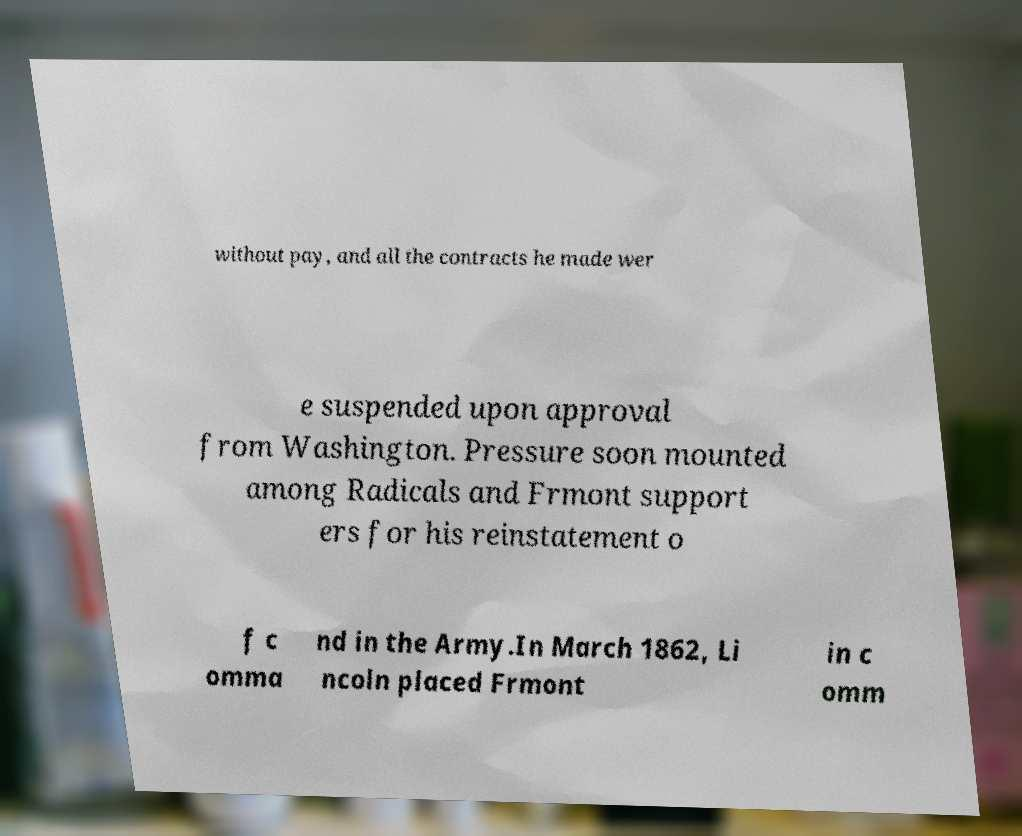For documentation purposes, I need the text within this image transcribed. Could you provide that? without pay, and all the contracts he made wer e suspended upon approval from Washington. Pressure soon mounted among Radicals and Frmont support ers for his reinstatement o f c omma nd in the Army.In March 1862, Li ncoln placed Frmont in c omm 